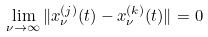<formula> <loc_0><loc_0><loc_500><loc_500>\lim _ { \nu \rightarrow \infty } \| x _ { \nu } ^ { ( j ) } ( t ) - x _ { \nu } ^ { ( k ) } ( t ) \| = 0</formula> 